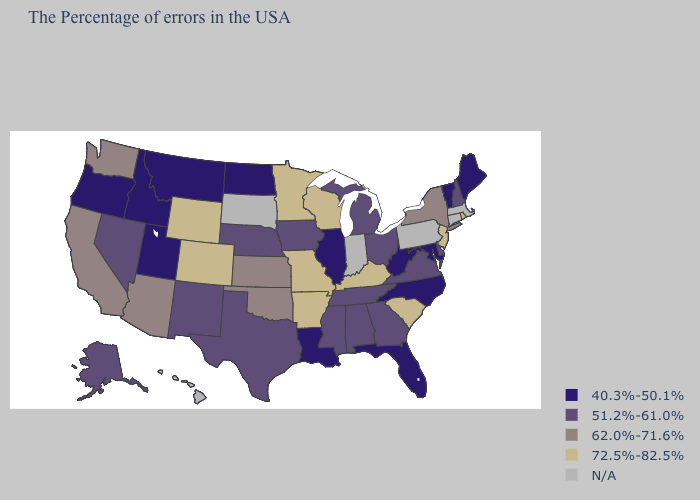Name the states that have a value in the range 40.3%-50.1%?
Keep it brief. Maine, Vermont, Maryland, North Carolina, West Virginia, Florida, Illinois, Louisiana, North Dakota, Utah, Montana, Idaho, Oregon. Does Wisconsin have the highest value in the MidWest?
Keep it brief. Yes. Does the map have missing data?
Write a very short answer. Yes. What is the highest value in the West ?
Answer briefly. 72.5%-82.5%. Name the states that have a value in the range 62.0%-71.6%?
Answer briefly. New York, Kansas, Oklahoma, Arizona, California, Washington. What is the value of Florida?
Keep it brief. 40.3%-50.1%. What is the value of Montana?
Be succinct. 40.3%-50.1%. Name the states that have a value in the range 51.2%-61.0%?
Write a very short answer. New Hampshire, Delaware, Virginia, Ohio, Georgia, Michigan, Alabama, Tennessee, Mississippi, Iowa, Nebraska, Texas, New Mexico, Nevada, Alaska. Name the states that have a value in the range 62.0%-71.6%?
Quick response, please. New York, Kansas, Oklahoma, Arizona, California, Washington. Which states have the lowest value in the South?
Be succinct. Maryland, North Carolina, West Virginia, Florida, Louisiana. Among the states that border Ohio , does West Virginia have the lowest value?
Write a very short answer. Yes. What is the lowest value in the West?
Quick response, please. 40.3%-50.1%. What is the highest value in the West ?
Short answer required. 72.5%-82.5%. Name the states that have a value in the range N/A?
Write a very short answer. Massachusetts, Connecticut, Pennsylvania, Indiana, South Dakota, Hawaii. Name the states that have a value in the range 72.5%-82.5%?
Answer briefly. Rhode Island, New Jersey, South Carolina, Kentucky, Wisconsin, Missouri, Arkansas, Minnesota, Wyoming, Colorado. 